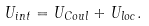<formula> <loc_0><loc_0><loc_500><loc_500>U _ { i n t } = U _ { C o u l } + U _ { l o c } .</formula> 